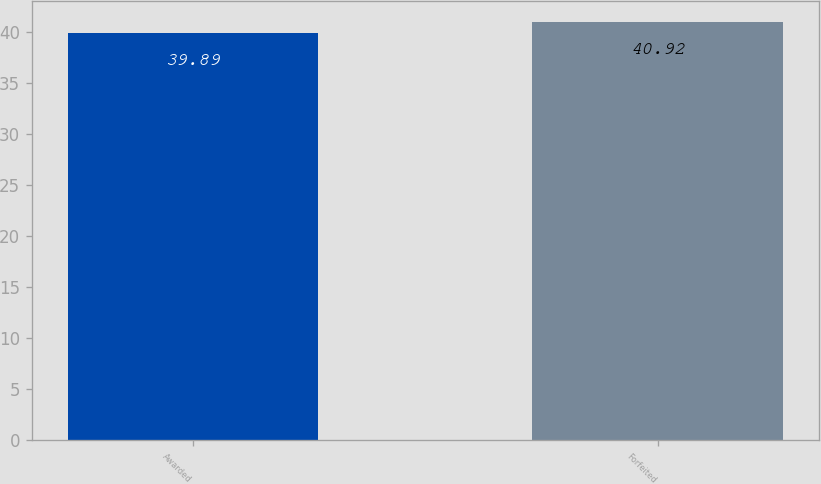<chart> <loc_0><loc_0><loc_500><loc_500><bar_chart><fcel>Awarded<fcel>Forfeited<nl><fcel>39.89<fcel>40.92<nl></chart> 